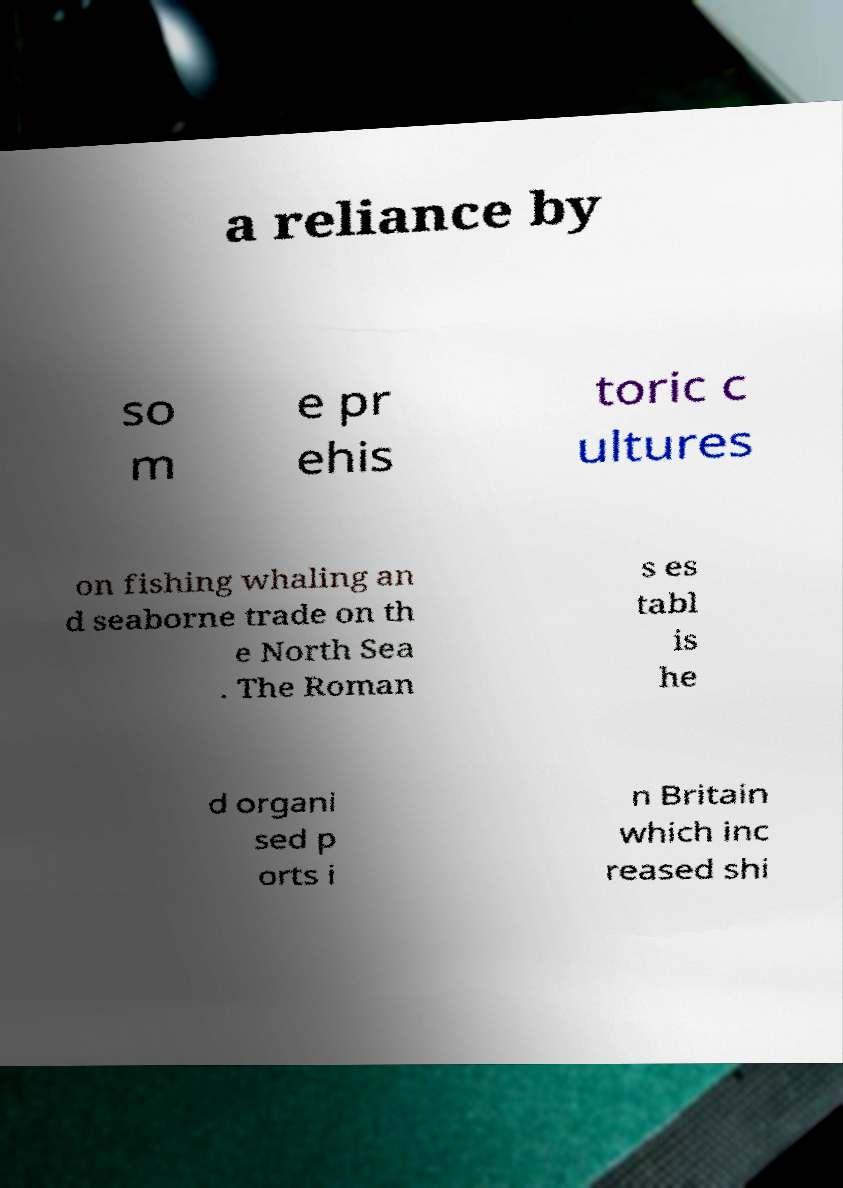What messages or text are displayed in this image? I need them in a readable, typed format. a reliance by so m e pr ehis toric c ultures on fishing whaling an d seaborne trade on th e North Sea . The Roman s es tabl is he d organi sed p orts i n Britain which inc reased shi 